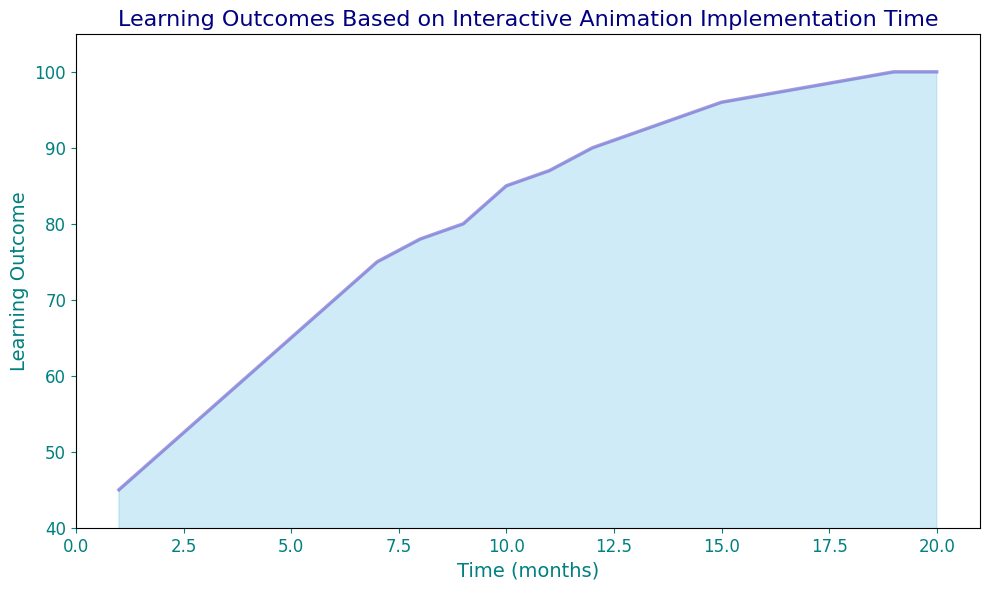What's the learning outcome at 10 months? Look at the point on the x-axis corresponding to 10 months and check the value on the y-axis.
Answer: 85 By how much does the learning outcome increase from 1 month to 5 months? Find the y-values for 1 month (45) and 5 months (65), then subtract the first from the second (65 - 45).
Answer: 20 At which point does the learning outcome reach 90? Look along the y-axis to find the value 90, then trace horizontally to intersect the line, and read off the corresponding x-axis value, which is approximately between 12 and 13 months.
Answer: 12 What's the average learning outcome in the first 10 months? Sum the learning outcomes from month 1 to month 10 (45 + 50 + 55 + 60 + 65 + 70 + 75 + 78 + 80 + 85 = 663) and divide by 10.
Answer: 66.3 Compare the rate of change in the learning outcome between 1-5 months and 10-15 months. Which period has a higher rate? For 1-5 months: (65-45)/4 = 5; For 10-15 months: (96-85)/5 = 2.2. The rate is higher in the 1-5 months period.
Answer: 1-5 months Describe the visual trend of the learning outcome over the 20 months. Initially, the learning outcome increases rapidly, then the rise gradually slows until it plateaus near 20 months.
Answer: Rapid increase and then plateaus What is the range of the learning outcomes depicted in the chart? Identify the minimum (45 at 1 month) and the maximum values (100 at 19-20 months), then compute the difference (100 - 45).
Answer: 55 Between which months does the learning outcome exceed 90 for the first time? Locate the y-axis value of 90 and track the corresponding point on the x-axis where it is first exceeded, which is between 12 and 13 months.
Answer: 12 and 13 How much did the learning outcome change between months 15 and 20? Find the learning outcomes at months 15 (96) and 20 (100), then subtract (100 - 96).
Answer: 4 